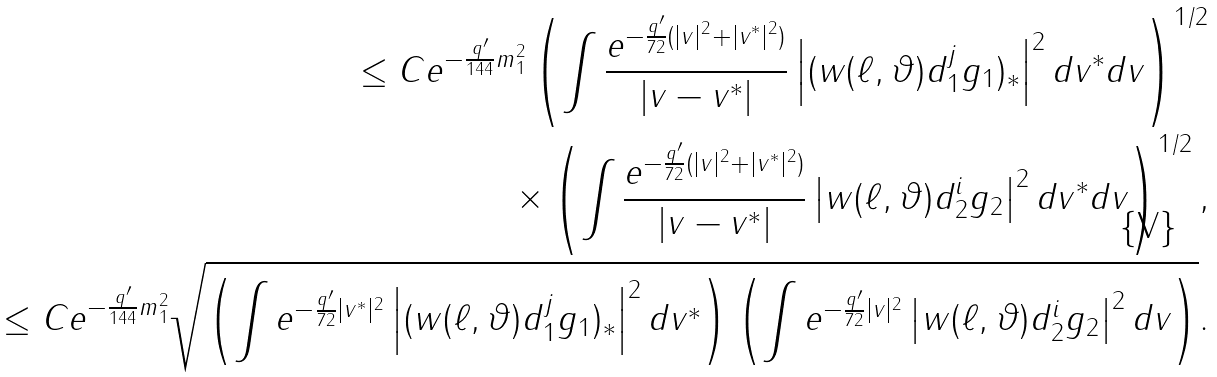<formula> <loc_0><loc_0><loc_500><loc_500>\leq C e ^ { - \frac { q ^ { \prime } } { 1 4 4 } m _ { 1 } ^ { 2 } } \left ( \int \frac { e ^ { - \frac { q ^ { \prime } } { 7 2 } ( | v | ^ { 2 } + | v ^ { * } | ^ { 2 } ) } } { | v - v ^ { * } | } \left | ( w ( \ell , \vartheta ) d _ { 1 } ^ { j } g _ { 1 } ) _ { * } \right | ^ { 2 } d v ^ { * } d v \right ) ^ { 1 / 2 } \\ \times \left ( \int \frac { e ^ { - \frac { q ^ { \prime } } { 7 2 } ( | v | ^ { 2 } + | v ^ { * } | ^ { 2 } ) } } { | v - v ^ { * } | } \left | w ( \ell , \vartheta ) d _ { 2 } ^ { i } g _ { 2 } \right | ^ { 2 } d v ^ { * } d v \right ) ^ { 1 / 2 } , \\ \leq C e ^ { - \frac { q ^ { \prime } } { 1 4 4 } m _ { 1 } ^ { 2 } } \sqrt { \left ( \int e ^ { - \frac { q ^ { \prime } } { 7 2 } | v ^ { * } | ^ { 2 } } \left | ( w ( \ell , \vartheta ) d _ { 1 } ^ { j } g _ { 1 } ) _ { * } \right | ^ { 2 } d v ^ { * } \right ) \left ( \int e ^ { - \frac { q ^ { \prime } } { 7 2 } | v | ^ { 2 } } \left | w ( \ell , \vartheta ) d _ { 2 } ^ { i } g _ { 2 } \right | ^ { 2 } d v \right ) } .</formula> 